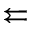Convert formula to latex. <formula><loc_0><loc_0><loc_500><loc_500>\left l e f t a r r o w s</formula> 